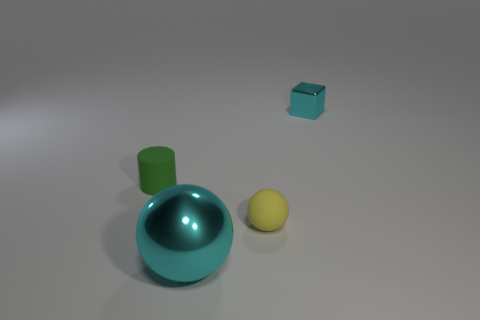Add 2 small yellow rubber balls. How many objects exist? 6 Subtract all cylinders. How many objects are left? 3 Subtract all small shiny things. Subtract all rubber cylinders. How many objects are left? 2 Add 3 small shiny blocks. How many small shiny blocks are left? 4 Add 2 tiny red matte spheres. How many tiny red matte spheres exist? 2 Subtract 1 cyan cubes. How many objects are left? 3 